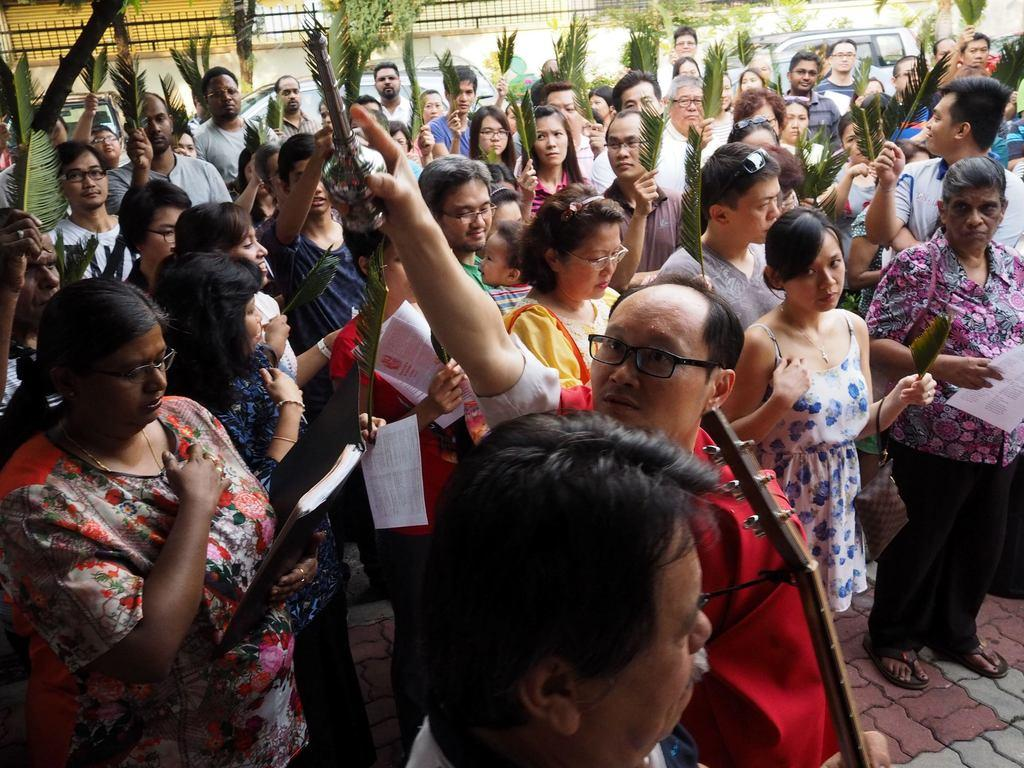How many people are in the image? There is a group of persons in the image. What are the persons in the image doing? The persons are standing and holding an object. What else can be seen in the image besides the group of persons? A: There are vehicles, plants, and a wall in the image. What is the persons' opinions on the cup in the image? There is no cup present in the image, so it is not possible to determine their opinions on it. 